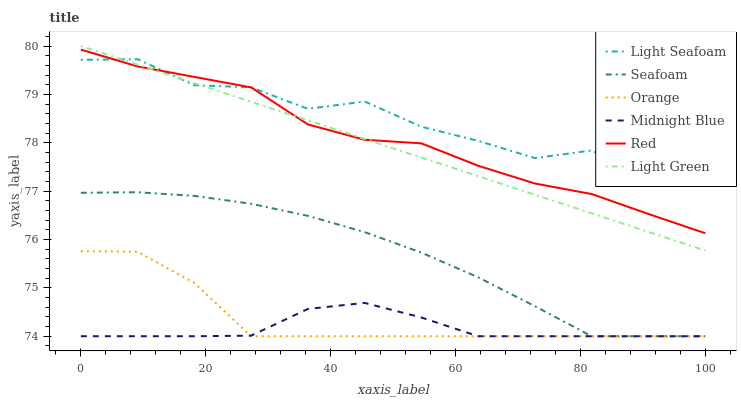Does Midnight Blue have the minimum area under the curve?
Answer yes or no. Yes. Does Light Seafoam have the maximum area under the curve?
Answer yes or no. Yes. Does Seafoam have the minimum area under the curve?
Answer yes or no. No. Does Seafoam have the maximum area under the curve?
Answer yes or no. No. Is Light Green the smoothest?
Answer yes or no. Yes. Is Light Seafoam the roughest?
Answer yes or no. Yes. Is Seafoam the smoothest?
Answer yes or no. No. Is Seafoam the roughest?
Answer yes or no. No. Does Midnight Blue have the lowest value?
Answer yes or no. Yes. Does Light Green have the lowest value?
Answer yes or no. No. Does Light Green have the highest value?
Answer yes or no. Yes. Does Seafoam have the highest value?
Answer yes or no. No. Is Orange less than Red?
Answer yes or no. Yes. Is Light Green greater than Orange?
Answer yes or no. Yes. Does Light Seafoam intersect Red?
Answer yes or no. Yes. Is Light Seafoam less than Red?
Answer yes or no. No. Is Light Seafoam greater than Red?
Answer yes or no. No. Does Orange intersect Red?
Answer yes or no. No. 